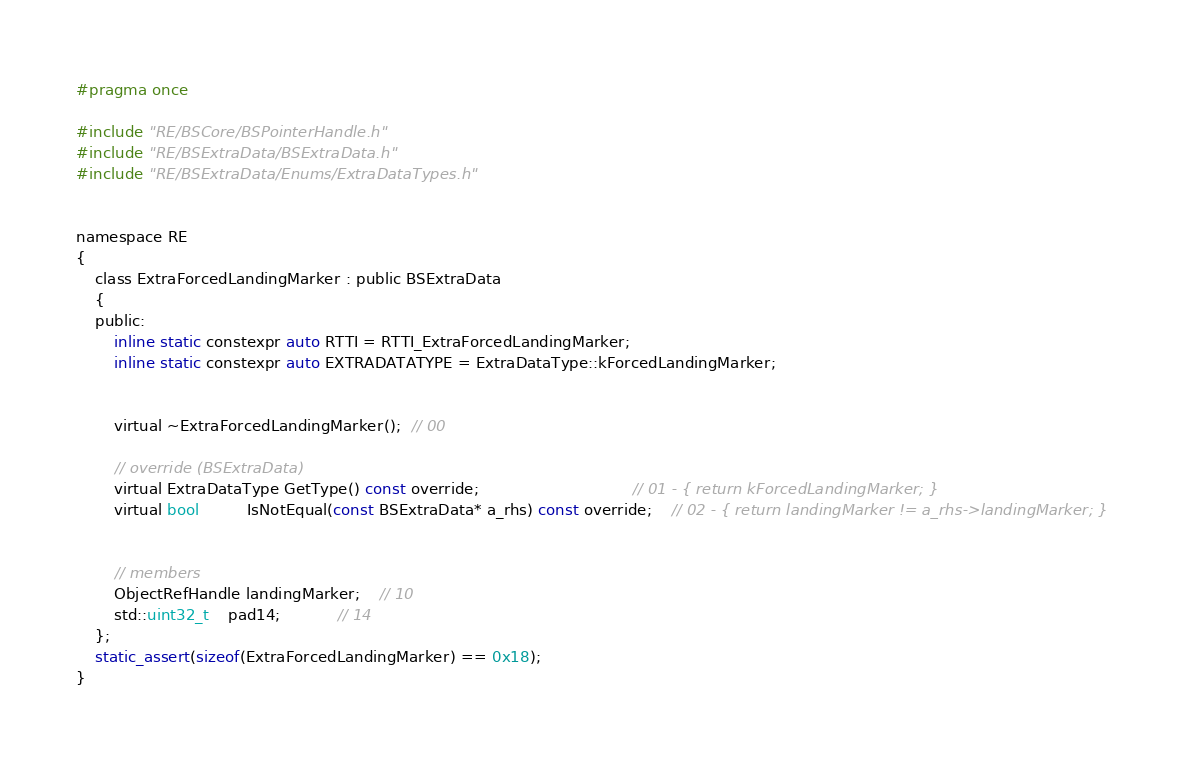<code> <loc_0><loc_0><loc_500><loc_500><_C_>#pragma once

#include "RE/BSCore/BSPointerHandle.h"
#include "RE/BSExtraData/BSExtraData.h"
#include "RE/BSExtraData/Enums/ExtraDataTypes.h"


namespace RE
{
	class ExtraForcedLandingMarker : public BSExtraData
	{
	public:
		inline static constexpr auto RTTI = RTTI_ExtraForcedLandingMarker;
		inline static constexpr auto EXTRADATATYPE = ExtraDataType::kForcedLandingMarker;


		virtual ~ExtraForcedLandingMarker();  // 00

		// override (BSExtraData)
		virtual ExtraDataType GetType() const override;								// 01 - { return kForcedLandingMarker; }
		virtual bool		  IsNotEqual(const BSExtraData* a_rhs) const override;	// 02 - { return landingMarker != a_rhs->landingMarker; }


		// members
		ObjectRefHandle landingMarker;	// 10
		std::uint32_t	pad14;			// 14
	};
	static_assert(sizeof(ExtraForcedLandingMarker) == 0x18);
}
</code> 